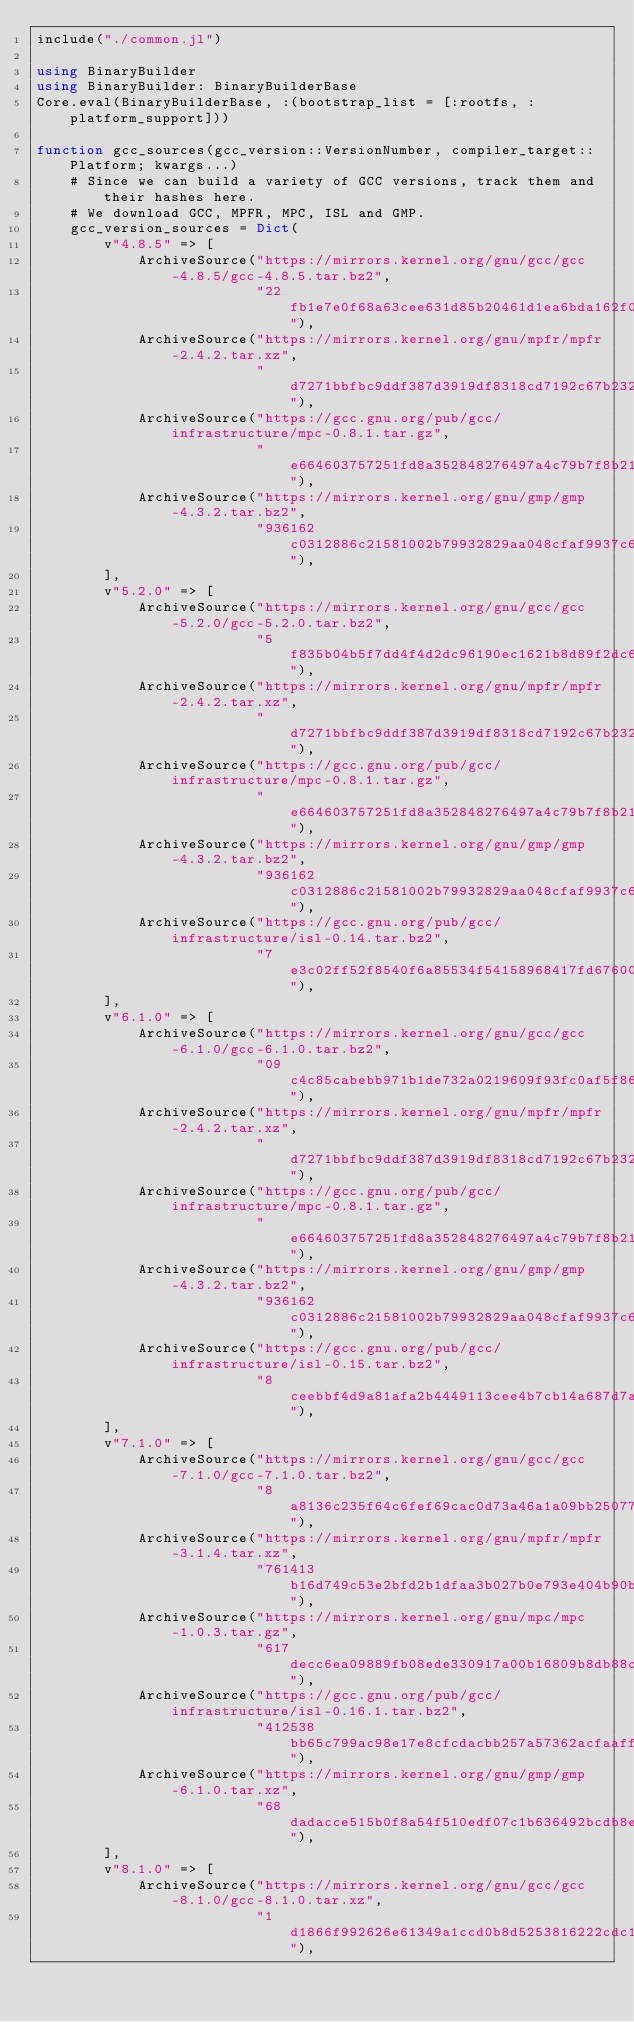<code> <loc_0><loc_0><loc_500><loc_500><_Julia_>include("./common.jl")

using BinaryBuilder
using BinaryBuilder: BinaryBuilderBase
Core.eval(BinaryBuilderBase, :(bootstrap_list = [:rootfs, :platform_support]))

function gcc_sources(gcc_version::VersionNumber, compiler_target::Platform; kwargs...)
    # Since we can build a variety of GCC versions, track them and their hashes here.
    # We download GCC, MPFR, MPC, ISL and GMP.
    gcc_version_sources = Dict(
        v"4.8.5" => [
            ArchiveSource("https://mirrors.kernel.org/gnu/gcc/gcc-4.8.5/gcc-4.8.5.tar.bz2",
                          "22fb1e7e0f68a63cee631d85b20461d1ea6bda162f03096350e38c8d427ecf23"),
            ArchiveSource("https://mirrors.kernel.org/gnu/mpfr/mpfr-2.4.2.tar.xz",
                          "d7271bbfbc9ddf387d3919df8318cd7192c67b232919bfa1cb3202d07843da1b"),
            ArchiveSource("https://gcc.gnu.org/pub/gcc/infrastructure/mpc-0.8.1.tar.gz",
                          "e664603757251fd8a352848276497a4c79b7f8b21fd8aedd5cc0598a38fee3e4"),
            ArchiveSource("https://mirrors.kernel.org/gnu/gmp/gmp-4.3.2.tar.bz2",
                          "936162c0312886c21581002b79932829aa048cfaf9937c6265aeaa14f1cd1775"),
        ],
        v"5.2.0" => [
            ArchiveSource("https://mirrors.kernel.org/gnu/gcc/gcc-5.2.0/gcc-5.2.0.tar.bz2",
                          "5f835b04b5f7dd4f4d2dc96190ec1621b8d89f2dc6f638f9f8bc1b1014ba8cad"),
            ArchiveSource("https://mirrors.kernel.org/gnu/mpfr/mpfr-2.4.2.tar.xz",
                          "d7271bbfbc9ddf387d3919df8318cd7192c67b232919bfa1cb3202d07843da1b"),
            ArchiveSource("https://gcc.gnu.org/pub/gcc/infrastructure/mpc-0.8.1.tar.gz",
                          "e664603757251fd8a352848276497a4c79b7f8b21fd8aedd5cc0598a38fee3e4"),
            ArchiveSource("https://mirrors.kernel.org/gnu/gmp/gmp-4.3.2.tar.bz2",
                          "936162c0312886c21581002b79932829aa048cfaf9937c6265aeaa14f1cd1775"),
            ArchiveSource("https://gcc.gnu.org/pub/gcc/infrastructure/isl-0.14.tar.bz2",
                          "7e3c02ff52f8540f6a85534f54158968417fd676001651c8289c705bd0228f36"),
        ],
        v"6.1.0" => [
            ArchiveSource("https://mirrors.kernel.org/gnu/gcc/gcc-6.1.0/gcc-6.1.0.tar.bz2",
                          "09c4c85cabebb971b1de732a0219609f93fc0af5f86f6e437fd8d7f832f1a351"),
            ArchiveSource("https://mirrors.kernel.org/gnu/mpfr/mpfr-2.4.2.tar.xz",
                          "d7271bbfbc9ddf387d3919df8318cd7192c67b232919bfa1cb3202d07843da1b"),
            ArchiveSource("https://gcc.gnu.org/pub/gcc/infrastructure/mpc-0.8.1.tar.gz",
                          "e664603757251fd8a352848276497a4c79b7f8b21fd8aedd5cc0598a38fee3e4"),
            ArchiveSource("https://mirrors.kernel.org/gnu/gmp/gmp-4.3.2.tar.bz2",
                          "936162c0312886c21581002b79932829aa048cfaf9937c6265aeaa14f1cd1775"),
            ArchiveSource("https://gcc.gnu.org/pub/gcc/infrastructure/isl-0.15.tar.bz2",
                          "8ceebbf4d9a81afa2b4449113cee4b7cb14a687d7a549a963deb5e2a41458b6b"),
        ],
        v"7.1.0" => [
            ArchiveSource("https://mirrors.kernel.org/gnu/gcc/gcc-7.1.0/gcc-7.1.0.tar.bz2",
                          "8a8136c235f64c6fef69cac0d73a46a1a09bb250776a050aec8f9fc880bebc17"),
            ArchiveSource("https://mirrors.kernel.org/gnu/mpfr/mpfr-3.1.4.tar.xz",
                          "761413b16d749c53e2bfd2b1dfaa3b027b0e793e404b90b5fbaeef60af6517f5"),
            ArchiveSource("https://mirrors.kernel.org/gnu/mpc/mpc-1.0.3.tar.gz",
                          "617decc6ea09889fb08ede330917a00b16809b8db88c29c31bfbb49cbf88ecc3"),
            ArchiveSource("https://gcc.gnu.org/pub/gcc/infrastructure/isl-0.16.1.tar.bz2",
                          "412538bb65c799ac98e17e8cfcdacbb257a57362acfaaff254b0fcae970126d2"),
            ArchiveSource("https://mirrors.kernel.org/gnu/gmp/gmp-6.1.0.tar.xz",
                          "68dadacce515b0f8a54f510edf07c1b636492bcdb8e8d54c56eb216225d16989"),
        ],
        v"8.1.0" => [
            ArchiveSource("https://mirrors.kernel.org/gnu/gcc/gcc-8.1.0/gcc-8.1.0.tar.xz",
                          "1d1866f992626e61349a1ccd0b8d5253816222cdc13390dcfaa74b093aa2b153"),</code> 